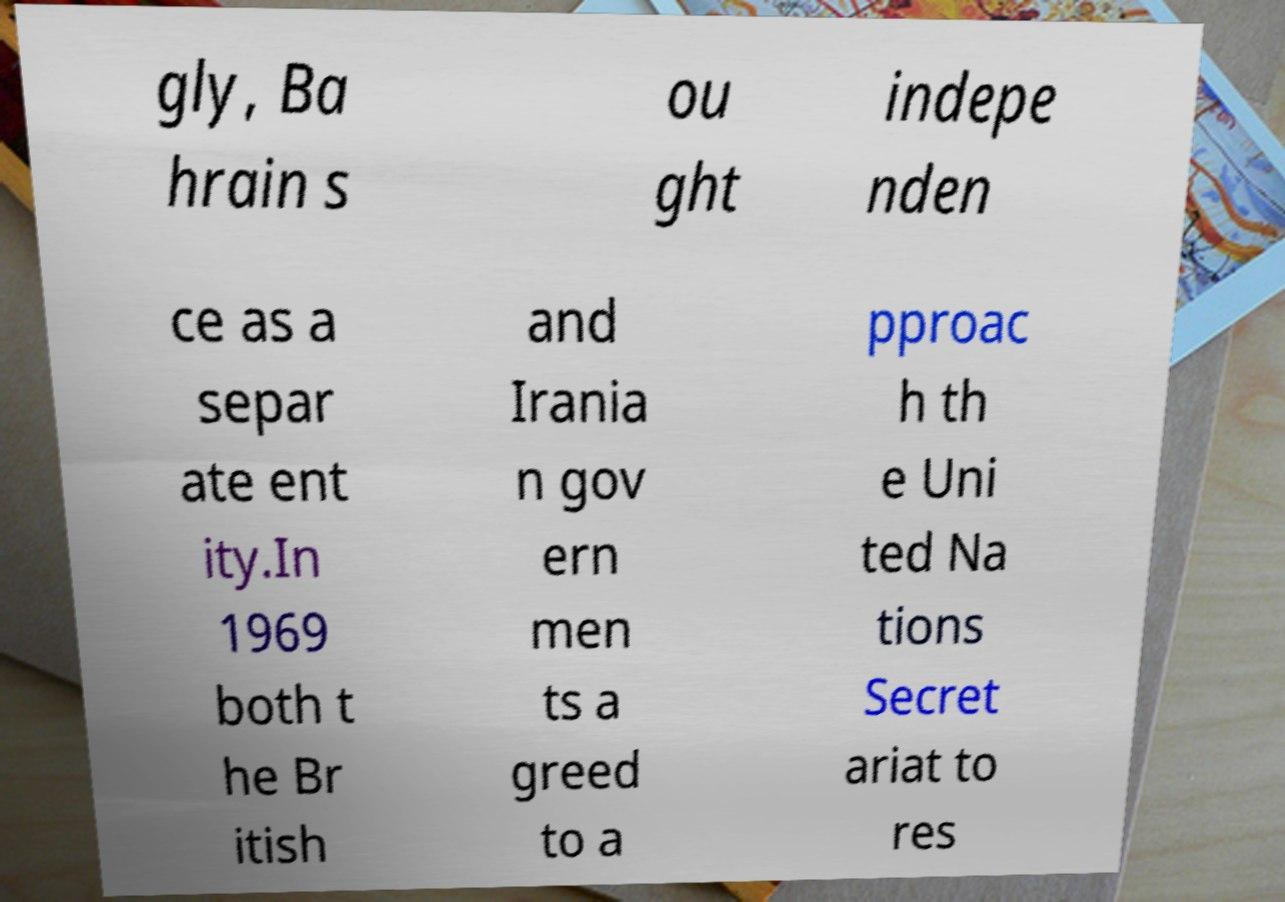Could you assist in decoding the text presented in this image and type it out clearly? gly, Ba hrain s ou ght indepe nden ce as a separ ate ent ity.In 1969 both t he Br itish and Irania n gov ern men ts a greed to a pproac h th e Uni ted Na tions Secret ariat to res 